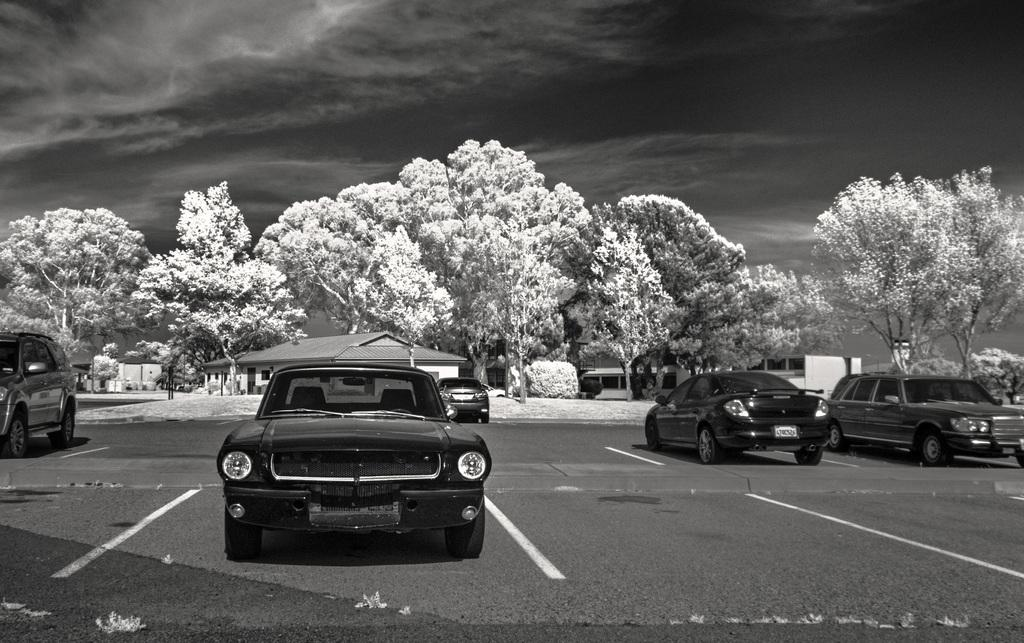What is the color scheme of the image? The image is black and white. What can be seen on the road in the image? There are cars on the road in the image. What type of vegetation is present in the image? There are trees and plants in the image. What type of structures can be seen in the image? There are houses in the image. What is visible in the background of the image? The sky with clouds is visible in the background of the image. Where are the dogs playing in the image? There are no dogs present in the image. What type of animals can be seen at the zoo in the image? There is no zoo present in the image. 